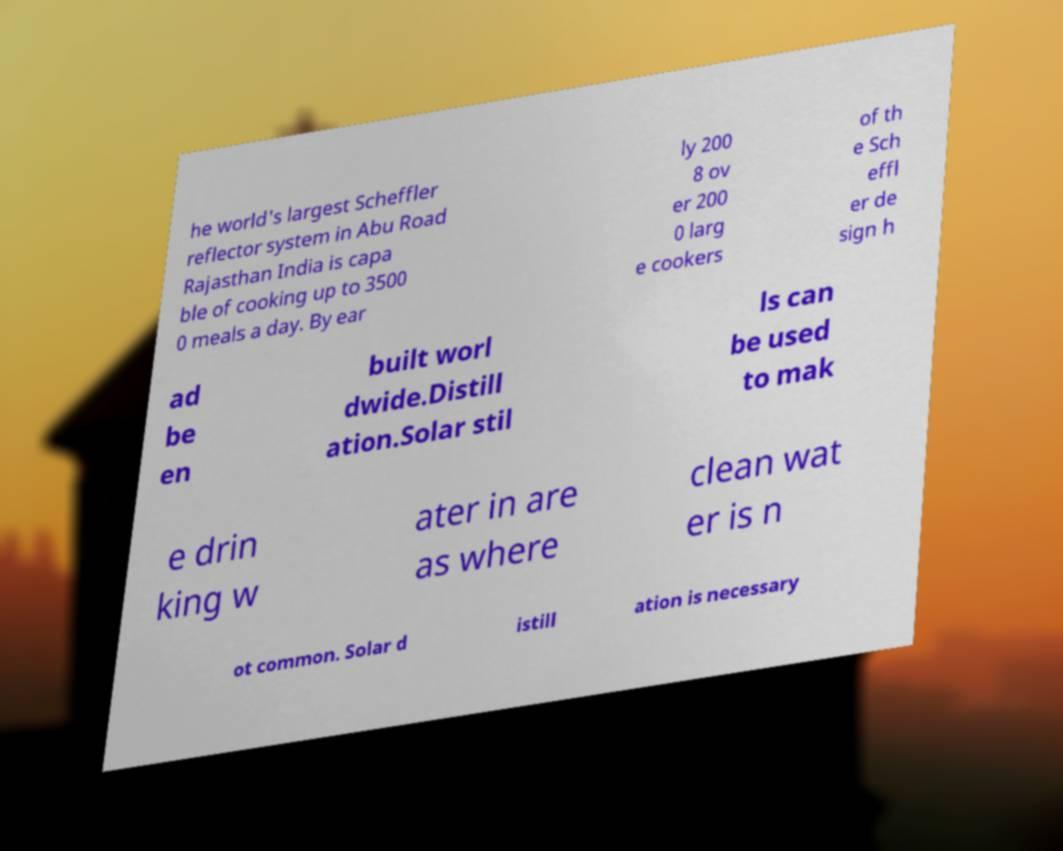For documentation purposes, I need the text within this image transcribed. Could you provide that? he world's largest Scheffler reflector system in Abu Road Rajasthan India is capa ble of cooking up to 3500 0 meals a day. By ear ly 200 8 ov er 200 0 larg e cookers of th e Sch effl er de sign h ad be en built worl dwide.Distill ation.Solar stil ls can be used to mak e drin king w ater in are as where clean wat er is n ot common. Solar d istill ation is necessary 